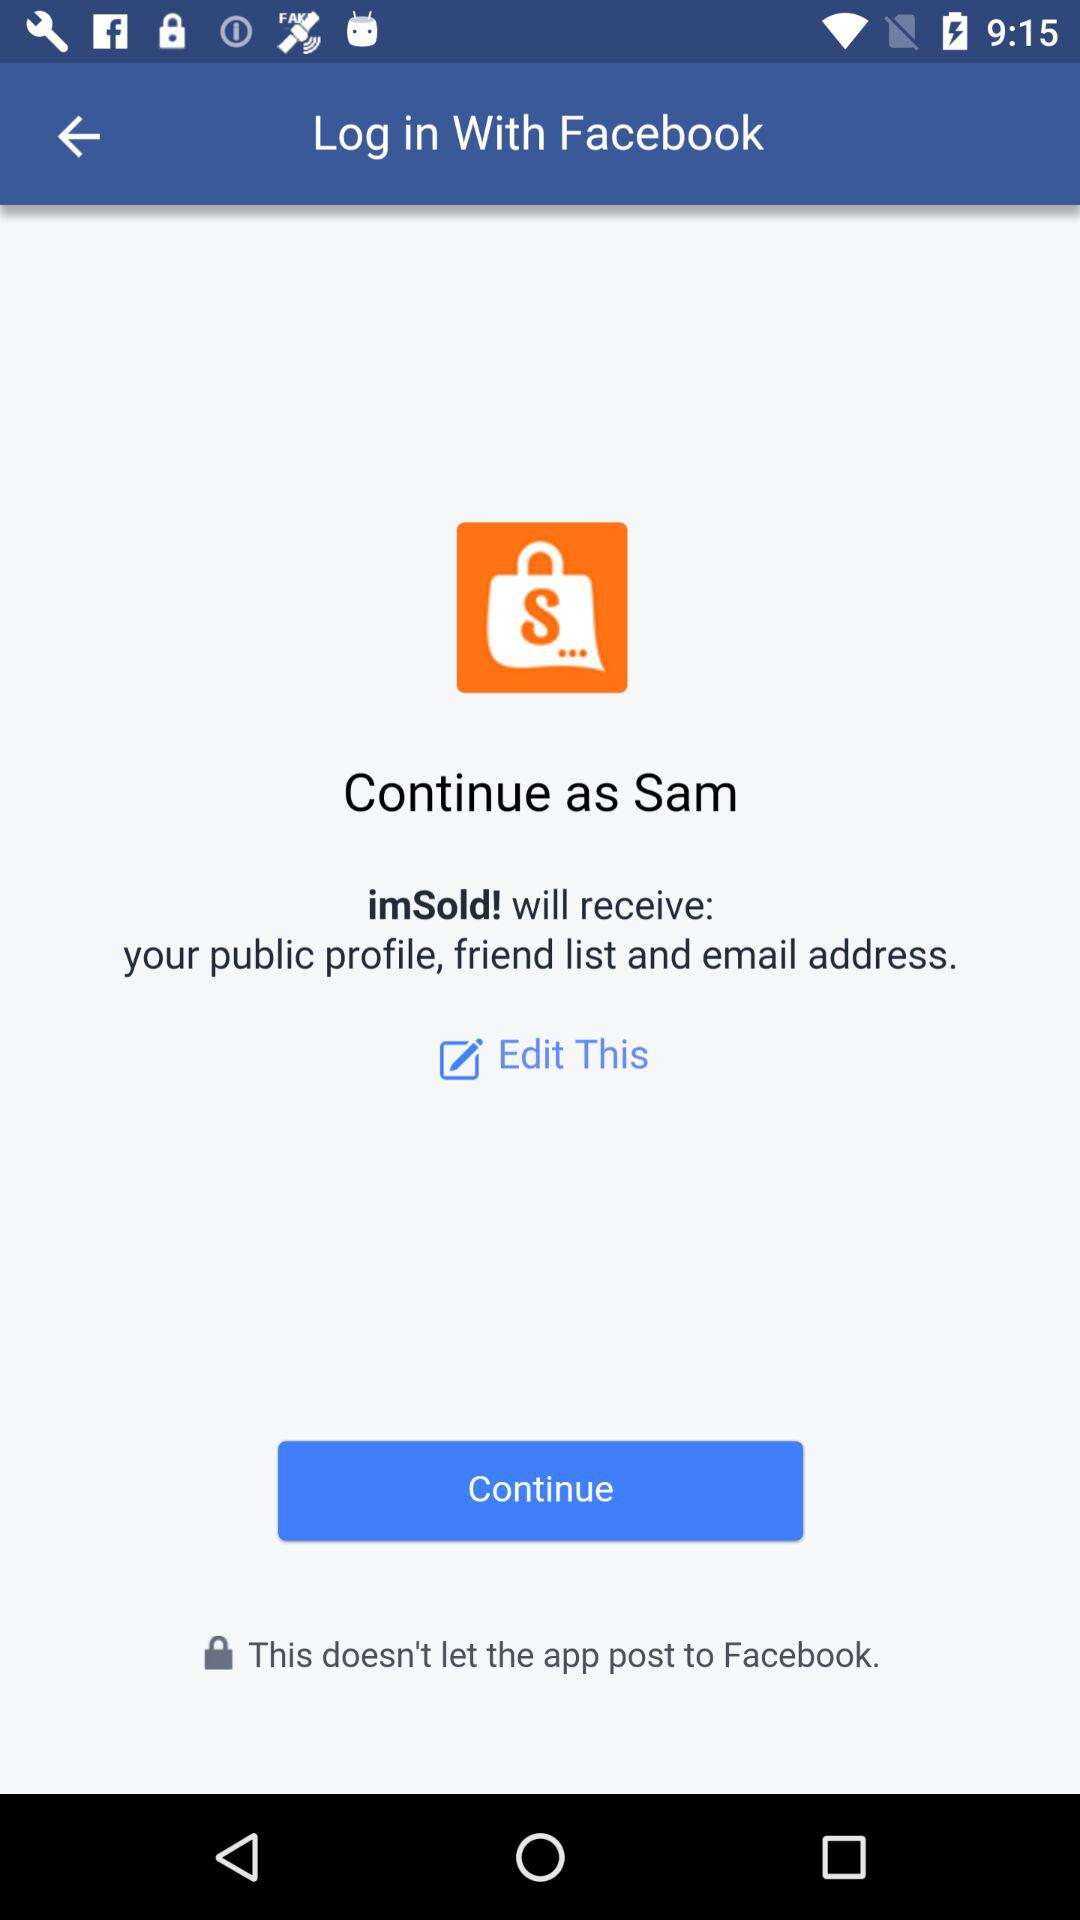What is the user name? The user name is "Sam". 